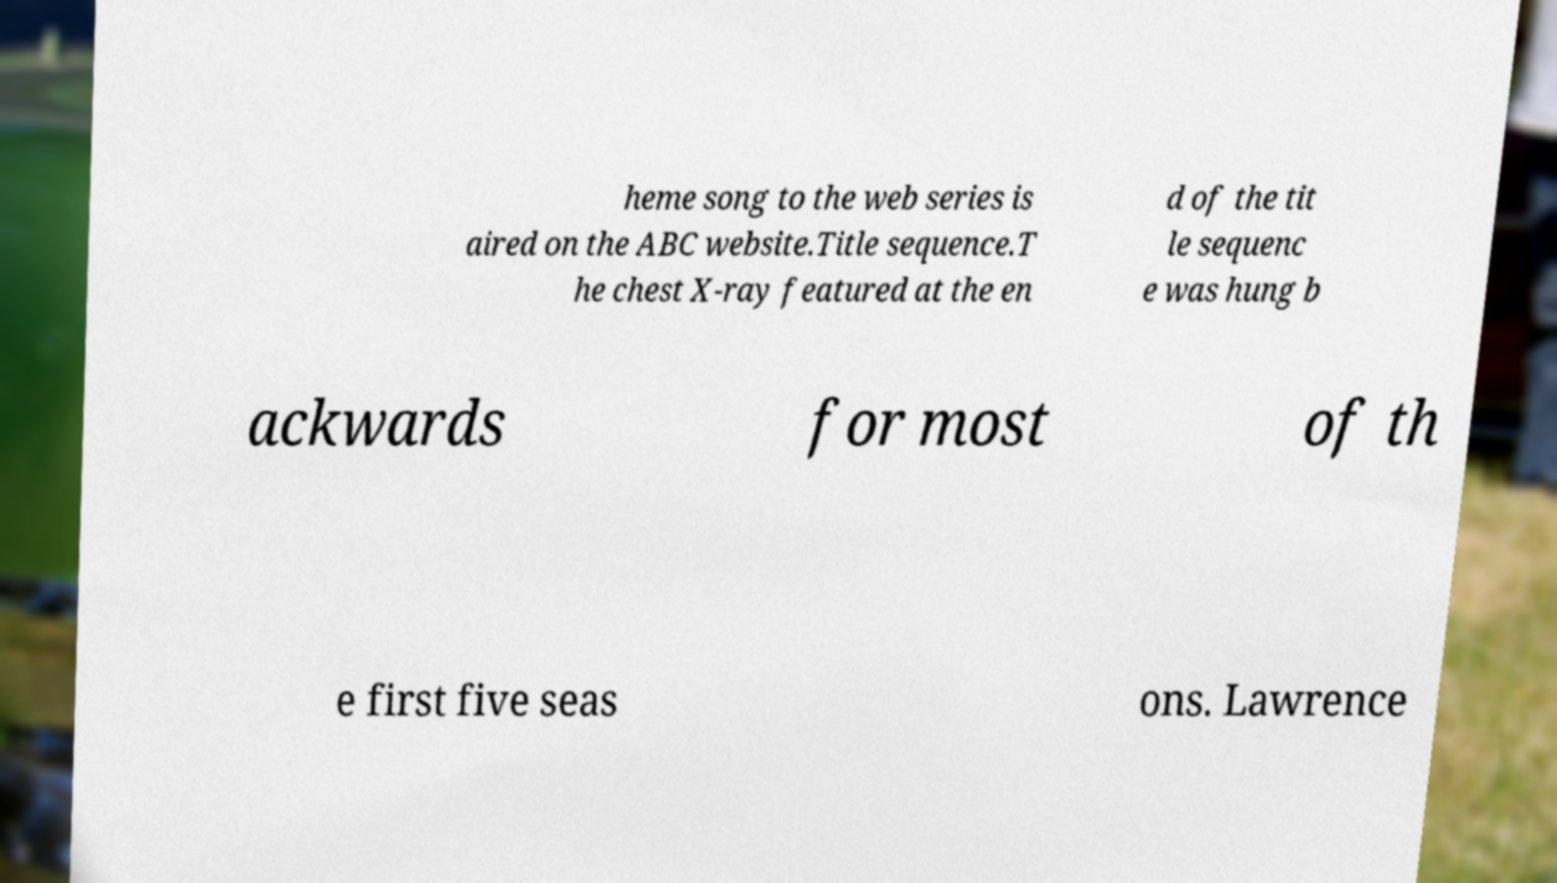Could you assist in decoding the text presented in this image and type it out clearly? heme song to the web series is aired on the ABC website.Title sequence.T he chest X-ray featured at the en d of the tit le sequenc e was hung b ackwards for most of th e first five seas ons. Lawrence 